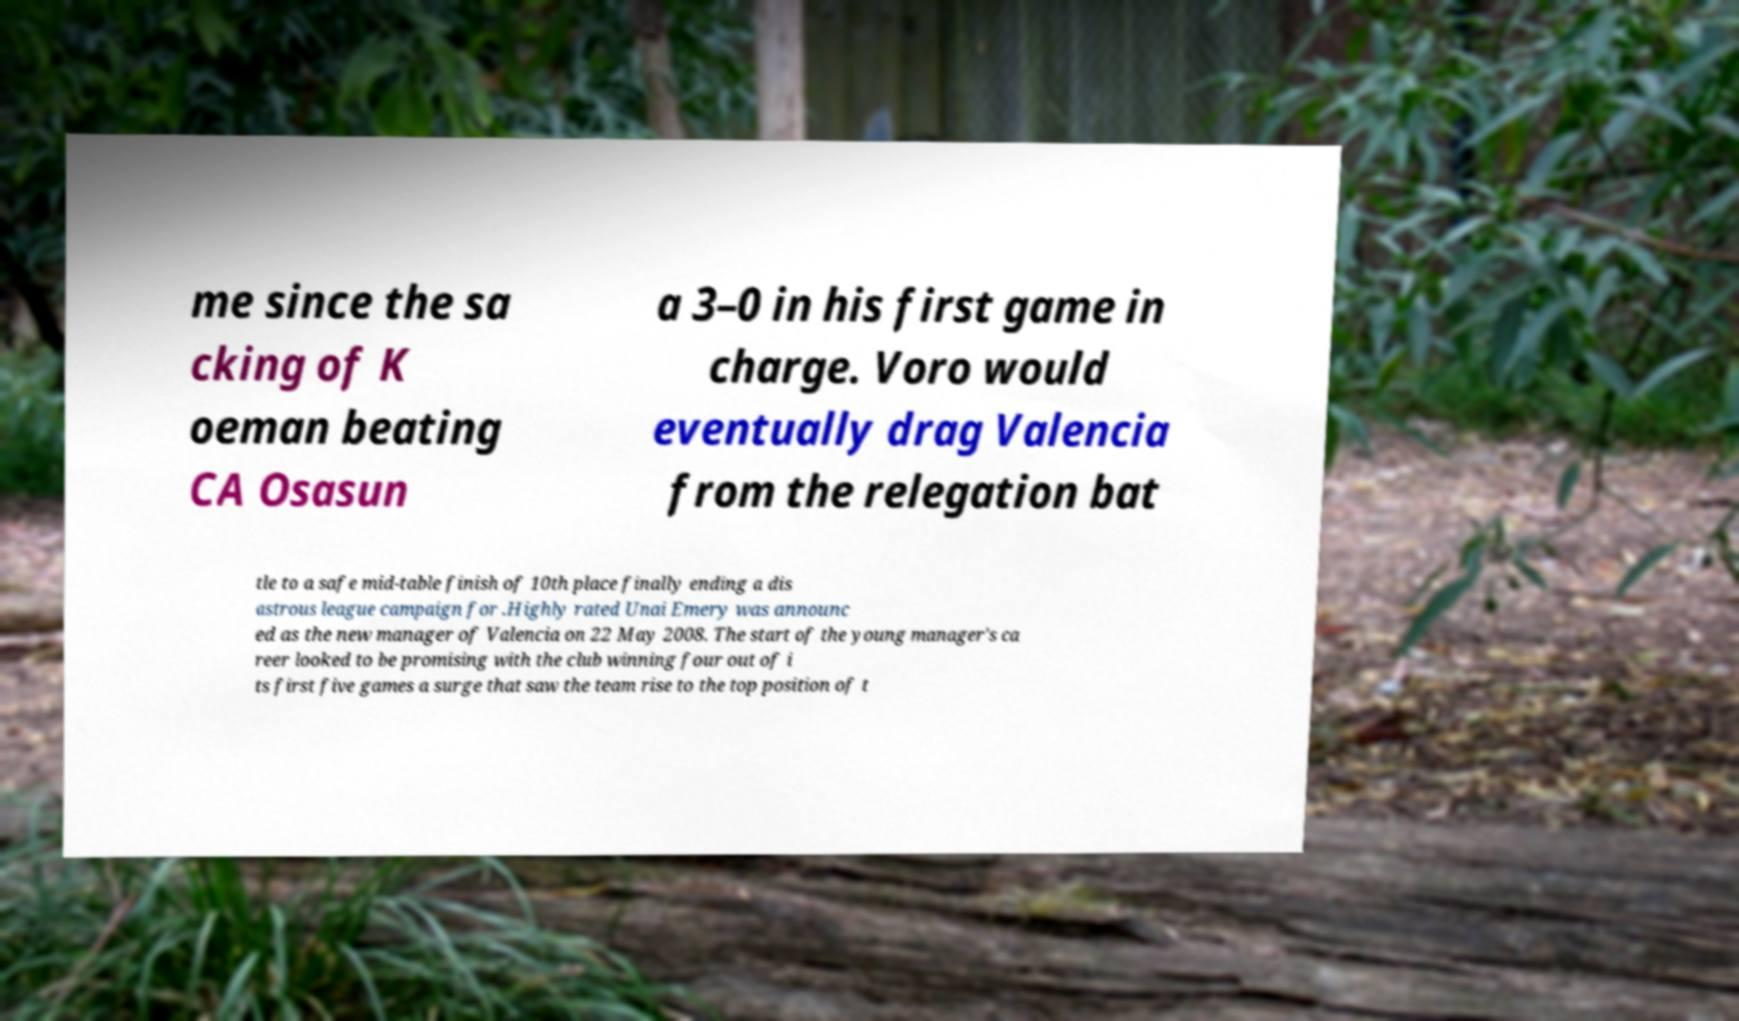Could you assist in decoding the text presented in this image and type it out clearly? me since the sa cking of K oeman beating CA Osasun a 3–0 in his first game in charge. Voro would eventually drag Valencia from the relegation bat tle to a safe mid-table finish of 10th place finally ending a dis astrous league campaign for .Highly rated Unai Emery was announc ed as the new manager of Valencia on 22 May 2008. The start of the young manager's ca reer looked to be promising with the club winning four out of i ts first five games a surge that saw the team rise to the top position of t 